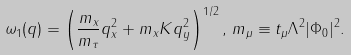<formula> <loc_0><loc_0><loc_500><loc_500>\omega _ { 1 } ( { q } ) = \left ( \frac { m _ { x } } { m _ { \tau } } q _ { x } ^ { 2 } + m _ { x } K q _ { y } ^ { 2 } \right ) ^ { 1 / 2 } , \, m _ { \mu } \equiv t _ { \mu } \Lambda ^ { 2 } | \Phi _ { 0 } | ^ { 2 } .</formula> 